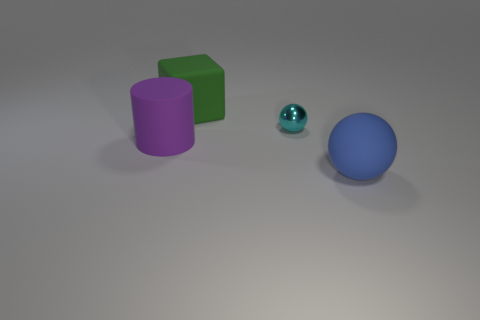There is another large thing that is the same shape as the cyan metal thing; what is its color?
Your answer should be very brief. Blue. There is a metallic thing that is the same shape as the big blue rubber object; what is its size?
Your response must be concise. Small. There is a ball to the right of the small cyan metal sphere; what number of matte cylinders are on the right side of it?
Your answer should be compact. 0. There is a cyan object; are there any objects right of it?
Give a very brief answer. Yes. There is a matte object behind the metal thing; is it the same shape as the large purple matte thing?
Give a very brief answer. No. How many big matte balls are the same color as the tiny ball?
Your answer should be compact. 0. There is a big object in front of the large purple thing that is in front of the green matte block; what shape is it?
Offer a very short reply. Sphere. Are there any small yellow rubber objects that have the same shape as the tiny cyan thing?
Give a very brief answer. No. There is a large ball; is it the same color as the sphere behind the big blue thing?
Give a very brief answer. No. Are there any blue rubber things that have the same size as the blue rubber ball?
Provide a succinct answer. No. 